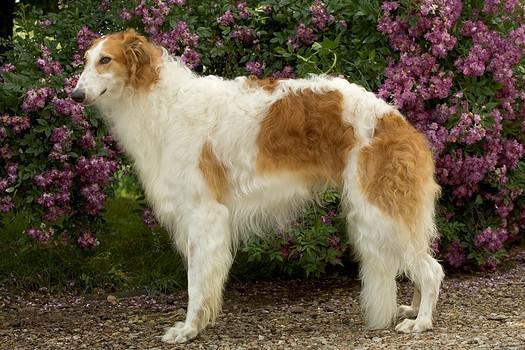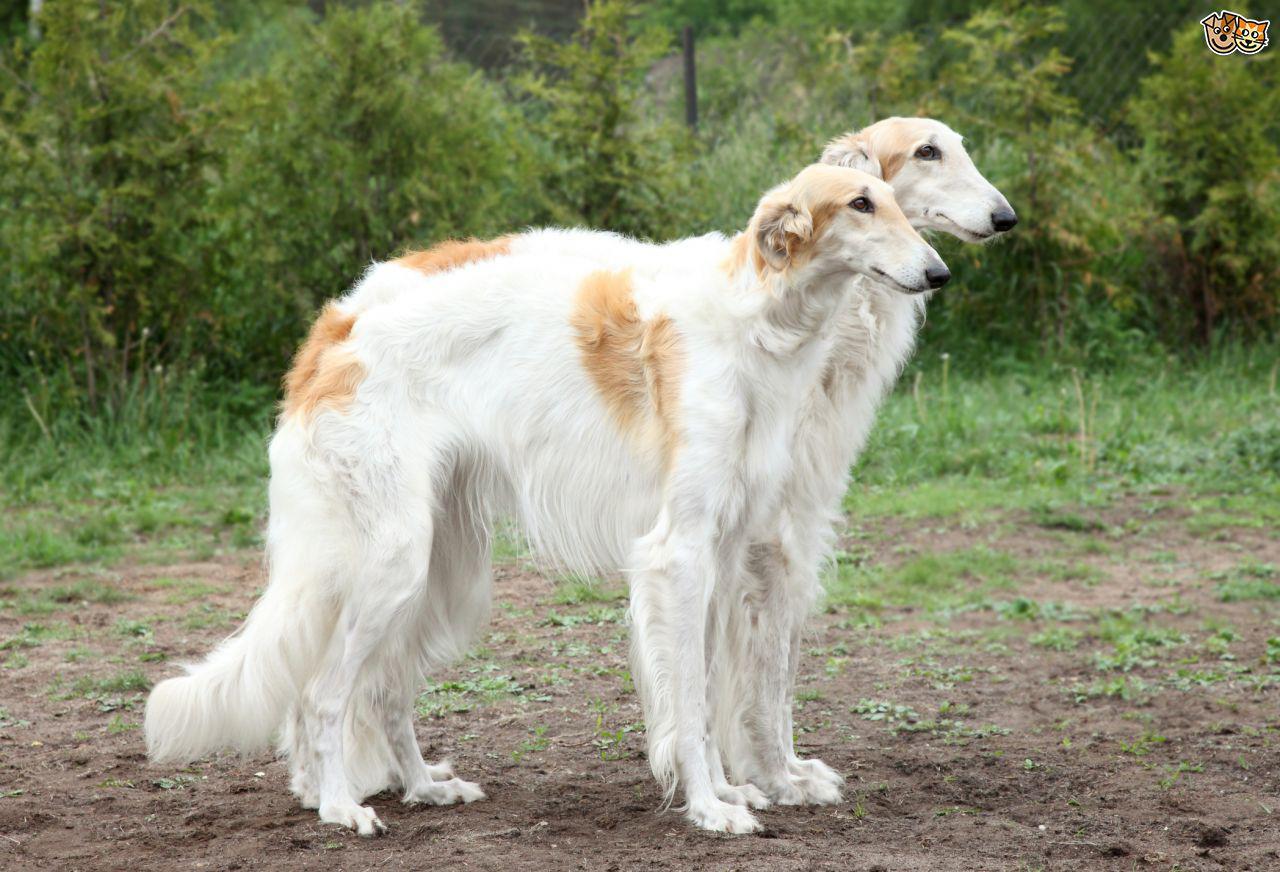The first image is the image on the left, the second image is the image on the right. Analyze the images presented: Is the assertion "The dog in the image on the left is facing left and the dog in the image on the right is facing right." valid? Answer yes or no. Yes. 